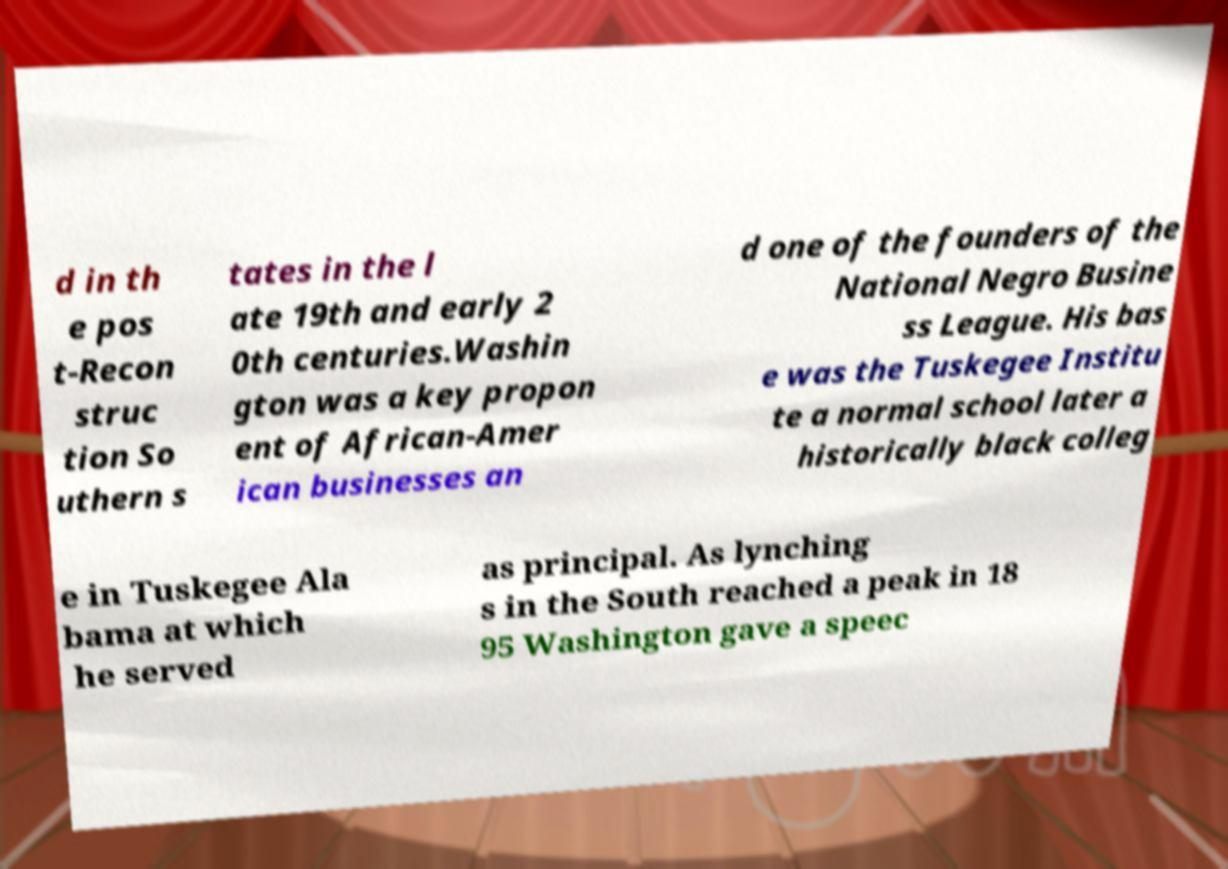Could you assist in decoding the text presented in this image and type it out clearly? d in th e pos t-Recon struc tion So uthern s tates in the l ate 19th and early 2 0th centuries.Washin gton was a key propon ent of African-Amer ican businesses an d one of the founders of the National Negro Busine ss League. His bas e was the Tuskegee Institu te a normal school later a historically black colleg e in Tuskegee Ala bama at which he served as principal. As lynching s in the South reached a peak in 18 95 Washington gave a speec 